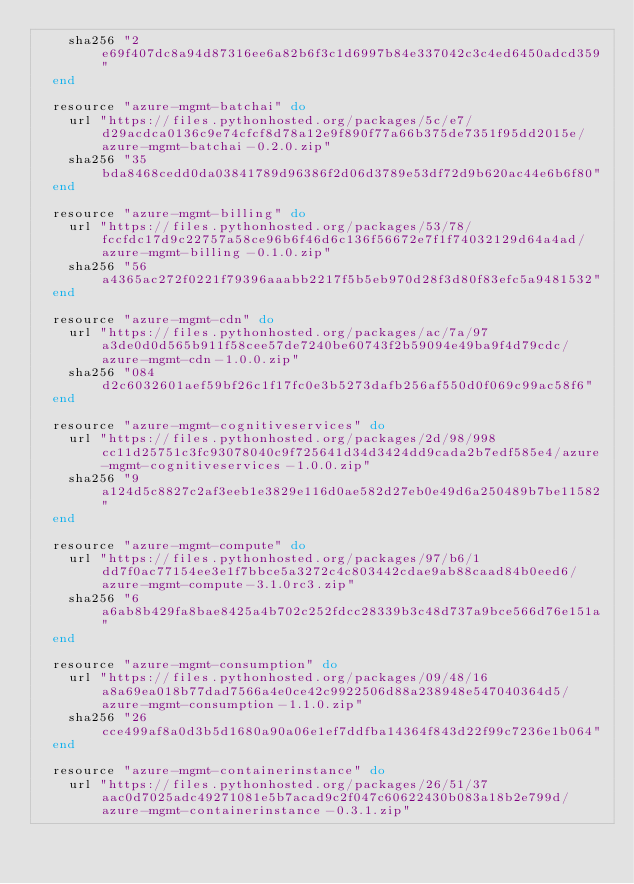Convert code to text. <code><loc_0><loc_0><loc_500><loc_500><_Ruby_>    sha256 "2e69f407dc8a94d87316ee6a82b6f3c1d6997b84e337042c3c4ed6450adcd359"
  end

  resource "azure-mgmt-batchai" do
    url "https://files.pythonhosted.org/packages/5c/e7/d29acdca0136c9e74cfcf8d78a12e9f890f77a66b375de7351f95dd2015e/azure-mgmt-batchai-0.2.0.zip"
    sha256 "35bda8468cedd0da03841789d96386f2d06d3789e53df72d9b620ac44e6b6f80"
  end

  resource "azure-mgmt-billing" do
    url "https://files.pythonhosted.org/packages/53/78/fccfdc17d9c22757a58ce96b6f46d6c136f56672e7f1f74032129d64a4ad/azure-mgmt-billing-0.1.0.zip"
    sha256 "56a4365ac272f0221f79396aaabb2217f5b5eb970d28f3d80f83efc5a9481532"
  end

  resource "azure-mgmt-cdn" do
    url "https://files.pythonhosted.org/packages/ac/7a/97a3de0d0d565b911f58cee57de7240be60743f2b59094e49ba9f4d79cdc/azure-mgmt-cdn-1.0.0.zip"
    sha256 "084d2c6032601aef59bf26c1f17fc0e3b5273dafb256af550d0f069c99ac58f6"
  end

  resource "azure-mgmt-cognitiveservices" do
    url "https://files.pythonhosted.org/packages/2d/98/998cc11d25751c3fc93078040c9f725641d34d3424dd9cada2b7edf585e4/azure-mgmt-cognitiveservices-1.0.0.zip"
    sha256 "9a124d5c8827c2af3eeb1e3829e116d0ae582d27eb0e49d6a250489b7be11582"
  end

  resource "azure-mgmt-compute" do
    url "https://files.pythonhosted.org/packages/97/b6/1dd7f0ac77154ee3e1f7bbce5a3272c4c803442cdae9ab88caad84b0eed6/azure-mgmt-compute-3.1.0rc3.zip"
    sha256 "6a6ab8b429fa8bae8425a4b702c252fdcc28339b3c48d737a9bce566d76e151a"
  end

  resource "azure-mgmt-consumption" do
    url "https://files.pythonhosted.org/packages/09/48/16a8a69ea018b77dad7566a4e0ce42c9922506d88a238948e547040364d5/azure-mgmt-consumption-1.1.0.zip"
    sha256 "26cce499af8a0d3b5d1680a90a06e1ef7ddfba14364f843d22f99c7236e1b064"
  end

  resource "azure-mgmt-containerinstance" do
    url "https://files.pythonhosted.org/packages/26/51/37aac0d7025adc49271081e5b7acad9c2f047c60622430b083a18b2e799d/azure-mgmt-containerinstance-0.3.1.zip"</code> 